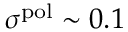<formula> <loc_0><loc_0><loc_500><loc_500>\sigma ^ { p o l } \sim 0 . 1</formula> 